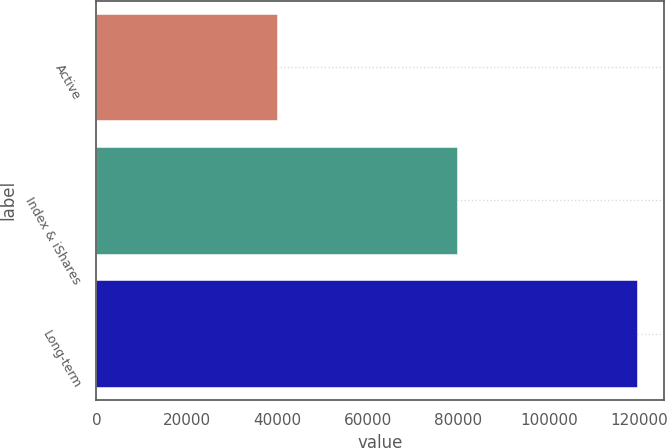Convert chart. <chart><loc_0><loc_0><loc_500><loc_500><bar_chart><fcel>Active<fcel>Index & iShares<fcel>Long-term<nl><fcel>39851<fcel>79628<fcel>119479<nl></chart> 